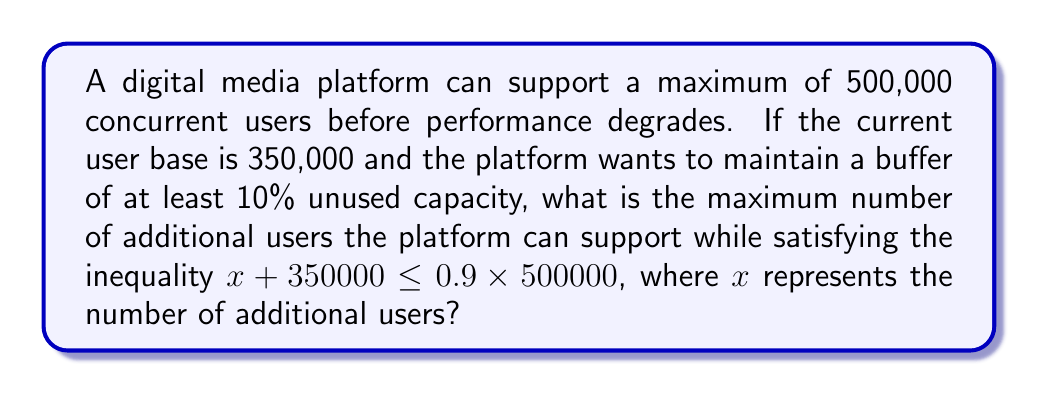Solve this math problem. Let's solve this step-by-step:

1) We start with the inequality:
   $x + 350000 \leq 0.9 \times 500000$

2) Simplify the right side of the inequality:
   $x + 350000 \leq 450000$

3) Subtract 350000 from both sides:
   $x \leq 450000 - 350000$

4) Simplify:
   $x \leq 100000$

5) Since $x$ represents the number of additional users, it must be a non-negative integer. Therefore, the maximum value for $x$ is the floor of 100000.

6) The floor of 100000 is 100000 itself, as it's already an integer.

Therefore, the maximum number of additional users the platform can support while maintaining the required buffer is 100,000.
Answer: 100,000 